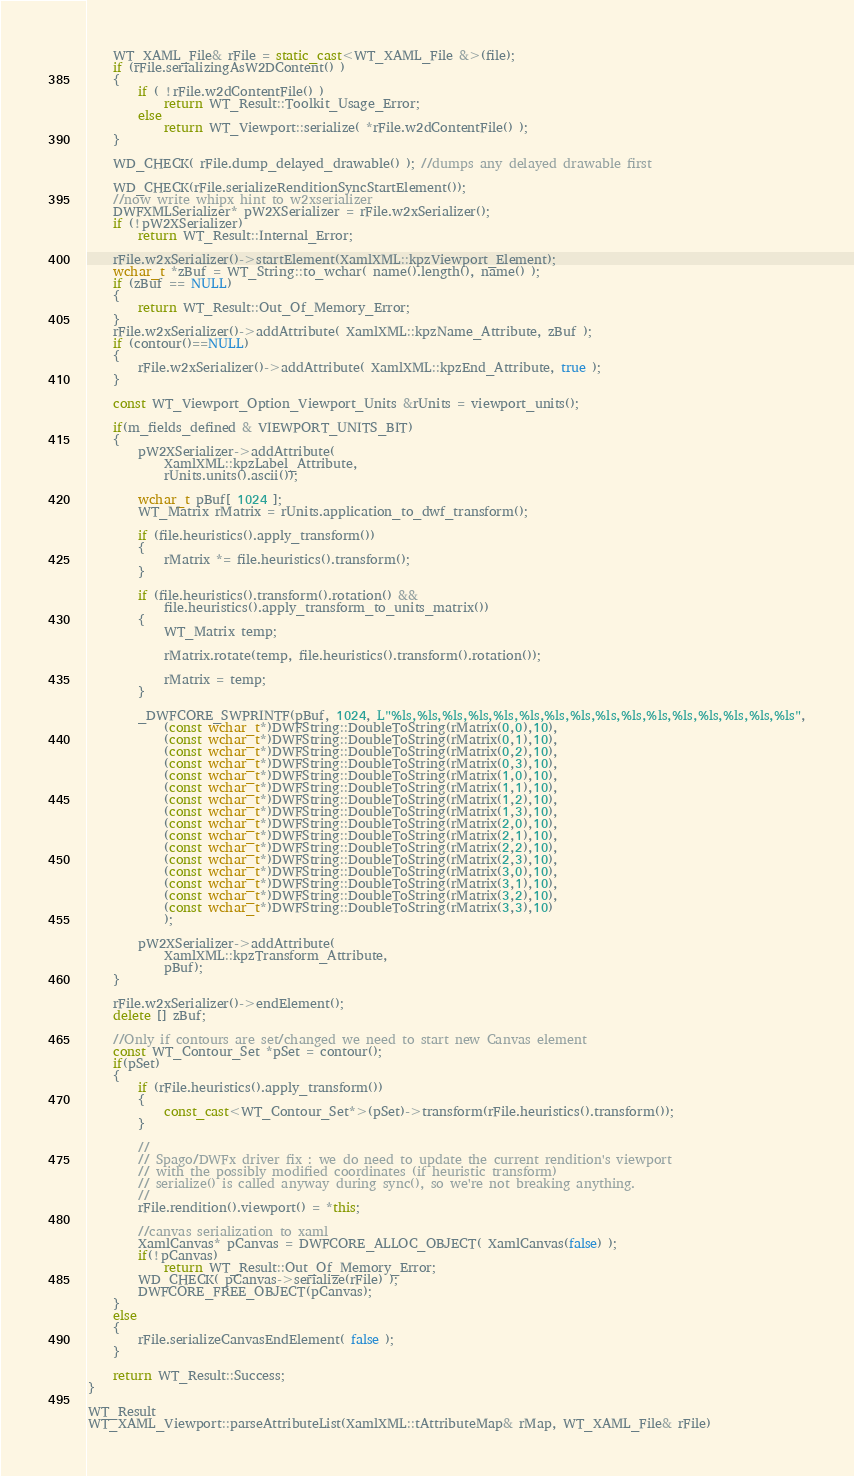Convert code to text. <code><loc_0><loc_0><loc_500><loc_500><_C++_>    WT_XAML_File& rFile = static_cast<WT_XAML_File &>(file);
    if (rFile.serializingAsW2DContent() )
    {
        if ( !rFile.w2dContentFile() )
            return WT_Result::Toolkit_Usage_Error;
        else
            return WT_Viewport::serialize( *rFile.w2dContentFile() );
    }

	WD_CHECK( rFile.dump_delayed_drawable() ); //dumps any delayed drawable first

    WD_CHECK(rFile.serializeRenditionSyncStartElement()); 
    //now write whipx hint to w2xserializer
	DWFXMLSerializer* pW2XSerializer = rFile.w2xSerializer();
	if (!pW2XSerializer)
		return WT_Result::Internal_Error;

    rFile.w2xSerializer()->startElement(XamlXML::kpzViewport_Element);
    wchar_t *zBuf = WT_String::to_wchar( name().length(), name() );
    if (zBuf == NULL)
    {
        return WT_Result::Out_Of_Memory_Error;
    }
	rFile.w2xSerializer()->addAttribute( XamlXML::kpzName_Attribute, zBuf );
    if (contour()==NULL)
    {
        rFile.w2xSerializer()->addAttribute( XamlXML::kpzEnd_Attribute, true );
    }

    const WT_Viewport_Option_Viewport_Units &rUnits = viewport_units(); 

    if(m_fields_defined & VIEWPORT_UNITS_BIT) 
    { 
        pW2XSerializer->addAttribute( 
            XamlXML::kpzLabel_Attribute, 
            rUnits.units().ascii()); 

        wchar_t pBuf[ 1024 ]; 
        WT_Matrix rMatrix = rUnits.application_to_dwf_transform(); 

        if (file.heuristics().apply_transform()) 
        { 
            rMatrix *= file.heuristics().transform(); 
        } 

        if (file.heuristics().transform().rotation() && 
            file.heuristics().apply_transform_to_units_matrix()) 
        { 
            WT_Matrix temp; 

            rMatrix.rotate(temp, file.heuristics().transform().rotation()); 

            rMatrix = temp; 
        } 

        _DWFCORE_SWPRINTF(pBuf, 1024, L"%ls,%ls,%ls,%ls,%ls,%ls,%ls,%ls,%ls,%ls,%ls,%ls,%ls,%ls,%ls,%ls",
            (const wchar_t*)DWFString::DoubleToString(rMatrix(0,0),10), 
            (const wchar_t*)DWFString::DoubleToString(rMatrix(0,1),10), 
            (const wchar_t*)DWFString::DoubleToString(rMatrix(0,2),10), 
            (const wchar_t*)DWFString::DoubleToString(rMatrix(0,3),10), 
            (const wchar_t*)DWFString::DoubleToString(rMatrix(1,0),10), 
            (const wchar_t*)DWFString::DoubleToString(rMatrix(1,1),10), 
            (const wchar_t*)DWFString::DoubleToString(rMatrix(1,2),10), 
            (const wchar_t*)DWFString::DoubleToString(rMatrix(1,3),10), 
            (const wchar_t*)DWFString::DoubleToString(rMatrix(2,0),10), 
            (const wchar_t*)DWFString::DoubleToString(rMatrix(2,1),10), 
            (const wchar_t*)DWFString::DoubleToString(rMatrix(2,2),10), 
            (const wchar_t*)DWFString::DoubleToString(rMatrix(2,3),10), 
            (const wchar_t*)DWFString::DoubleToString(rMatrix(3,0),10), 
            (const wchar_t*)DWFString::DoubleToString(rMatrix(3,1),10), 
            (const wchar_t*)DWFString::DoubleToString(rMatrix(3,2),10), 
            (const wchar_t*)DWFString::DoubleToString(rMatrix(3,3),10) 
            ); 

        pW2XSerializer->addAttribute( 
            XamlXML::kpzTransform_Attribute, 
            pBuf); 
    } 

    rFile.w2xSerializer()->endElement();
    delete [] zBuf;

	//Only if contours are set/changed we need to start new Canvas element
	const WT_Contour_Set *pSet = contour();
    if(pSet)
	{
        if (rFile.heuristics().apply_transform())
        {
            const_cast<WT_Contour_Set*>(pSet)->transform(rFile.heuristics().transform());
        }

        //
        // Spago/DWFx driver fix : we do need to update the current rendition's viewport
        // with the possibly modified coordinates (if heuristic transform)
        // serialize() is called anyway during sync(), so we're not breaking anything.
        //
        rFile.rendition().viewport() = *this;

		//canvas serialization to xaml
		XamlCanvas* pCanvas = DWFCORE_ALLOC_OBJECT( XamlCanvas(false) );
		if(!pCanvas)
			return WT_Result::Out_Of_Memory_Error;
		WD_CHECK( pCanvas->serialize(rFile) );
		DWFCORE_FREE_OBJECT(pCanvas);
	}
    else
    {
        rFile.serializeCanvasEndElement( false );
    }

    return WT_Result::Success;
}

WT_Result
WT_XAML_Viewport::parseAttributeList(XamlXML::tAttributeMap& rMap, WT_XAML_File& rFile)</code> 